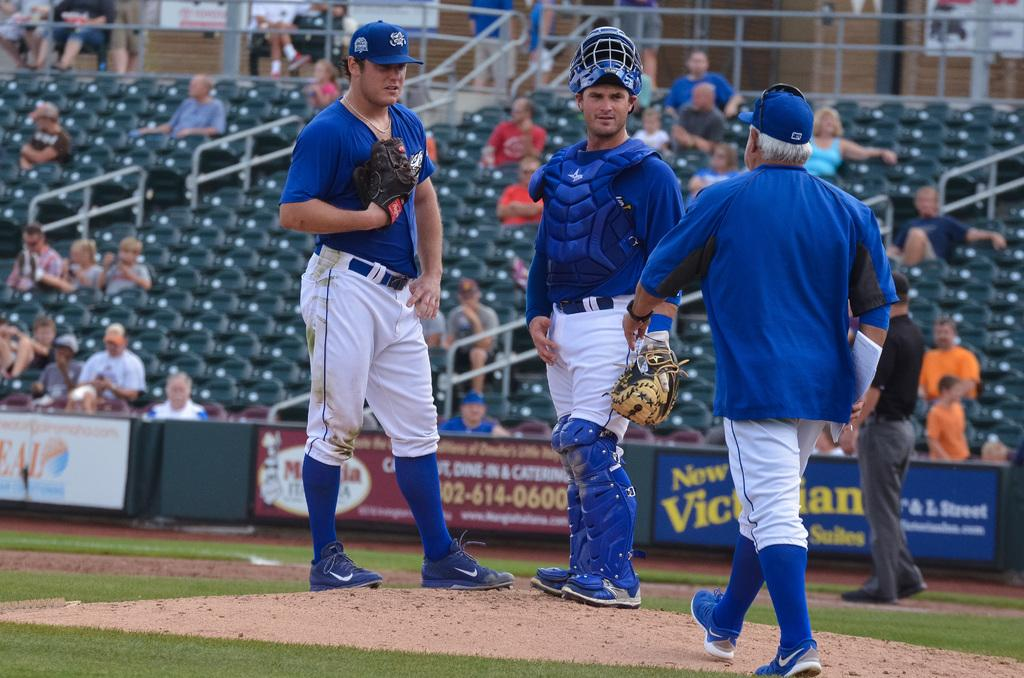Provide a one-sentence caption for the provided image. A pitcher wearing a Rawlings glove is being visited by the manager. 